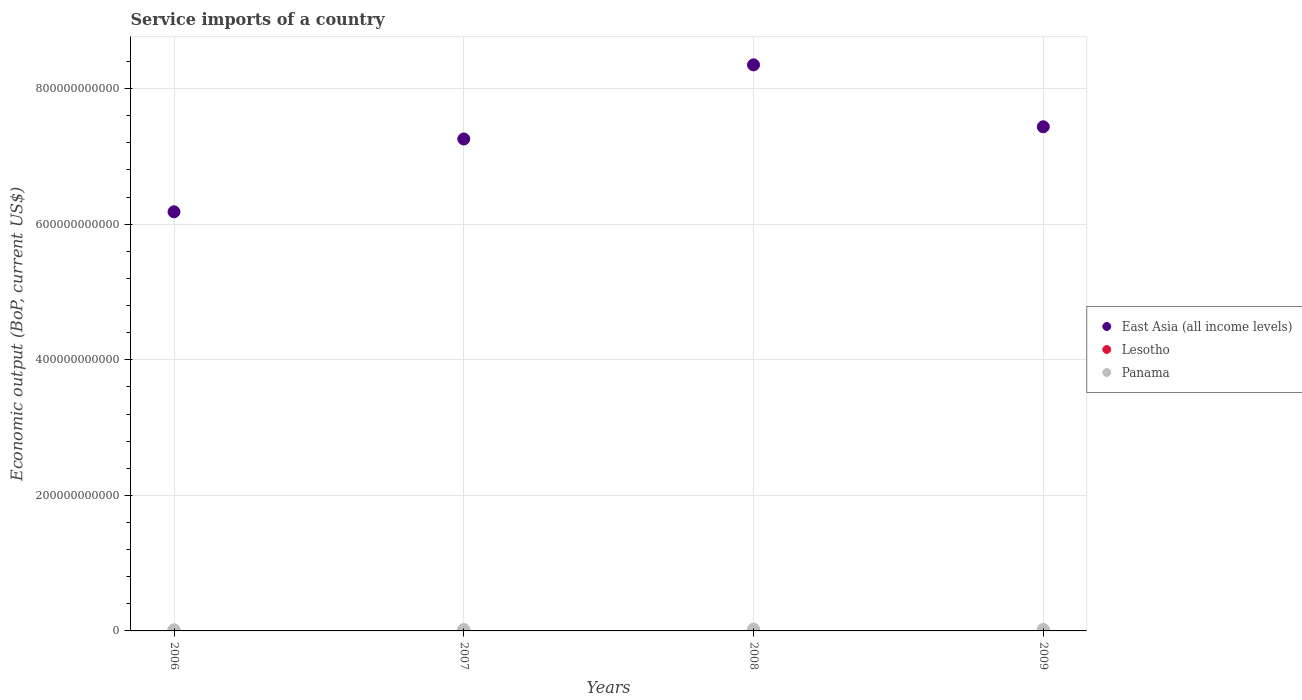Is the number of dotlines equal to the number of legend labels?
Provide a succinct answer. Yes. What is the service imports in Panama in 2006?
Your answer should be compact. 1.70e+09. Across all years, what is the maximum service imports in East Asia (all income levels)?
Offer a terse response. 8.35e+11. Across all years, what is the minimum service imports in Lesotho?
Offer a terse response. 3.76e+08. In which year was the service imports in Lesotho minimum?
Make the answer very short. 2007. What is the total service imports in East Asia (all income levels) in the graph?
Provide a short and direct response. 2.92e+12. What is the difference between the service imports in Panama in 2008 and that in 2009?
Your answer should be compact. 4.44e+08. What is the difference between the service imports in Lesotho in 2006 and the service imports in East Asia (all income levels) in 2009?
Provide a succinct answer. -7.43e+11. What is the average service imports in Lesotho per year?
Provide a short and direct response. 3.97e+08. In the year 2009, what is the difference between the service imports in East Asia (all income levels) and service imports in Panama?
Offer a very short reply. 7.42e+11. In how many years, is the service imports in East Asia (all income levels) greater than 800000000000 US$?
Provide a short and direct response. 1. What is the ratio of the service imports in Panama in 2007 to that in 2008?
Keep it short and to the point. 0.79. What is the difference between the highest and the second highest service imports in Lesotho?
Provide a short and direct response. 2.65e+07. What is the difference between the highest and the lowest service imports in Panama?
Give a very brief answer. 9.38e+08. In how many years, is the service imports in Panama greater than the average service imports in Panama taken over all years?
Offer a terse response. 2. Does the service imports in East Asia (all income levels) monotonically increase over the years?
Ensure brevity in your answer.  No. Is the service imports in Lesotho strictly less than the service imports in East Asia (all income levels) over the years?
Your response must be concise. Yes. How many years are there in the graph?
Offer a very short reply. 4. What is the difference between two consecutive major ticks on the Y-axis?
Your answer should be very brief. 2.00e+11. Where does the legend appear in the graph?
Your response must be concise. Center right. How many legend labels are there?
Make the answer very short. 3. How are the legend labels stacked?
Provide a short and direct response. Vertical. What is the title of the graph?
Offer a terse response. Service imports of a country. Does "Uzbekistan" appear as one of the legend labels in the graph?
Your answer should be compact. No. What is the label or title of the X-axis?
Make the answer very short. Years. What is the label or title of the Y-axis?
Your response must be concise. Economic output (BoP, current US$). What is the Economic output (BoP, current US$) in East Asia (all income levels) in 2006?
Provide a succinct answer. 6.18e+11. What is the Economic output (BoP, current US$) in Lesotho in 2006?
Keep it short and to the point. 3.78e+08. What is the Economic output (BoP, current US$) of Panama in 2006?
Offer a very short reply. 1.70e+09. What is the Economic output (BoP, current US$) of East Asia (all income levels) in 2007?
Provide a short and direct response. 7.26e+11. What is the Economic output (BoP, current US$) in Lesotho in 2007?
Make the answer very short. 3.76e+08. What is the Economic output (BoP, current US$) in Panama in 2007?
Offer a terse response. 2.09e+09. What is the Economic output (BoP, current US$) of East Asia (all income levels) in 2008?
Keep it short and to the point. 8.35e+11. What is the Economic output (BoP, current US$) of Lesotho in 2008?
Ensure brevity in your answer.  4.04e+08. What is the Economic output (BoP, current US$) in Panama in 2008?
Provide a short and direct response. 2.63e+09. What is the Economic output (BoP, current US$) in East Asia (all income levels) in 2009?
Give a very brief answer. 7.44e+11. What is the Economic output (BoP, current US$) of Lesotho in 2009?
Provide a short and direct response. 4.30e+08. What is the Economic output (BoP, current US$) in Panama in 2009?
Offer a terse response. 2.19e+09. Across all years, what is the maximum Economic output (BoP, current US$) in East Asia (all income levels)?
Your answer should be very brief. 8.35e+11. Across all years, what is the maximum Economic output (BoP, current US$) of Lesotho?
Ensure brevity in your answer.  4.30e+08. Across all years, what is the maximum Economic output (BoP, current US$) of Panama?
Offer a terse response. 2.63e+09. Across all years, what is the minimum Economic output (BoP, current US$) in East Asia (all income levels)?
Your response must be concise. 6.18e+11. Across all years, what is the minimum Economic output (BoP, current US$) of Lesotho?
Your answer should be compact. 3.76e+08. Across all years, what is the minimum Economic output (BoP, current US$) of Panama?
Offer a very short reply. 1.70e+09. What is the total Economic output (BoP, current US$) in East Asia (all income levels) in the graph?
Your answer should be compact. 2.92e+12. What is the total Economic output (BoP, current US$) in Lesotho in the graph?
Your response must be concise. 1.59e+09. What is the total Economic output (BoP, current US$) in Panama in the graph?
Ensure brevity in your answer.  8.61e+09. What is the difference between the Economic output (BoP, current US$) in East Asia (all income levels) in 2006 and that in 2007?
Offer a very short reply. -1.07e+11. What is the difference between the Economic output (BoP, current US$) of Lesotho in 2006 and that in 2007?
Provide a short and direct response. 2.02e+06. What is the difference between the Economic output (BoP, current US$) in Panama in 2006 and that in 2007?
Provide a short and direct response. -3.97e+08. What is the difference between the Economic output (BoP, current US$) in East Asia (all income levels) in 2006 and that in 2008?
Ensure brevity in your answer.  -2.17e+11. What is the difference between the Economic output (BoP, current US$) in Lesotho in 2006 and that in 2008?
Keep it short and to the point. -2.61e+07. What is the difference between the Economic output (BoP, current US$) of Panama in 2006 and that in 2008?
Your answer should be compact. -9.38e+08. What is the difference between the Economic output (BoP, current US$) of East Asia (all income levels) in 2006 and that in 2009?
Offer a very short reply. -1.25e+11. What is the difference between the Economic output (BoP, current US$) of Lesotho in 2006 and that in 2009?
Make the answer very short. -5.26e+07. What is the difference between the Economic output (BoP, current US$) of Panama in 2006 and that in 2009?
Ensure brevity in your answer.  -4.95e+08. What is the difference between the Economic output (BoP, current US$) in East Asia (all income levels) in 2007 and that in 2008?
Keep it short and to the point. -1.09e+11. What is the difference between the Economic output (BoP, current US$) of Lesotho in 2007 and that in 2008?
Your answer should be compact. -2.82e+07. What is the difference between the Economic output (BoP, current US$) in Panama in 2007 and that in 2008?
Your answer should be compact. -5.41e+08. What is the difference between the Economic output (BoP, current US$) of East Asia (all income levels) in 2007 and that in 2009?
Keep it short and to the point. -1.80e+1. What is the difference between the Economic output (BoP, current US$) of Lesotho in 2007 and that in 2009?
Offer a very short reply. -5.46e+07. What is the difference between the Economic output (BoP, current US$) of Panama in 2007 and that in 2009?
Provide a succinct answer. -9.79e+07. What is the difference between the Economic output (BoP, current US$) in East Asia (all income levels) in 2008 and that in 2009?
Provide a short and direct response. 9.13e+1. What is the difference between the Economic output (BoP, current US$) in Lesotho in 2008 and that in 2009?
Ensure brevity in your answer.  -2.65e+07. What is the difference between the Economic output (BoP, current US$) of Panama in 2008 and that in 2009?
Give a very brief answer. 4.44e+08. What is the difference between the Economic output (BoP, current US$) of East Asia (all income levels) in 2006 and the Economic output (BoP, current US$) of Lesotho in 2007?
Offer a very short reply. 6.18e+11. What is the difference between the Economic output (BoP, current US$) of East Asia (all income levels) in 2006 and the Economic output (BoP, current US$) of Panama in 2007?
Keep it short and to the point. 6.16e+11. What is the difference between the Economic output (BoP, current US$) in Lesotho in 2006 and the Economic output (BoP, current US$) in Panama in 2007?
Provide a short and direct response. -1.72e+09. What is the difference between the Economic output (BoP, current US$) of East Asia (all income levels) in 2006 and the Economic output (BoP, current US$) of Lesotho in 2008?
Your answer should be very brief. 6.18e+11. What is the difference between the Economic output (BoP, current US$) of East Asia (all income levels) in 2006 and the Economic output (BoP, current US$) of Panama in 2008?
Make the answer very short. 6.16e+11. What is the difference between the Economic output (BoP, current US$) in Lesotho in 2006 and the Economic output (BoP, current US$) in Panama in 2008?
Provide a short and direct response. -2.26e+09. What is the difference between the Economic output (BoP, current US$) in East Asia (all income levels) in 2006 and the Economic output (BoP, current US$) in Lesotho in 2009?
Keep it short and to the point. 6.18e+11. What is the difference between the Economic output (BoP, current US$) of East Asia (all income levels) in 2006 and the Economic output (BoP, current US$) of Panama in 2009?
Make the answer very short. 6.16e+11. What is the difference between the Economic output (BoP, current US$) of Lesotho in 2006 and the Economic output (BoP, current US$) of Panama in 2009?
Keep it short and to the point. -1.81e+09. What is the difference between the Economic output (BoP, current US$) of East Asia (all income levels) in 2007 and the Economic output (BoP, current US$) of Lesotho in 2008?
Make the answer very short. 7.25e+11. What is the difference between the Economic output (BoP, current US$) of East Asia (all income levels) in 2007 and the Economic output (BoP, current US$) of Panama in 2008?
Your answer should be very brief. 7.23e+11. What is the difference between the Economic output (BoP, current US$) in Lesotho in 2007 and the Economic output (BoP, current US$) in Panama in 2008?
Provide a short and direct response. -2.26e+09. What is the difference between the Economic output (BoP, current US$) of East Asia (all income levels) in 2007 and the Economic output (BoP, current US$) of Lesotho in 2009?
Keep it short and to the point. 7.25e+11. What is the difference between the Economic output (BoP, current US$) of East Asia (all income levels) in 2007 and the Economic output (BoP, current US$) of Panama in 2009?
Give a very brief answer. 7.24e+11. What is the difference between the Economic output (BoP, current US$) of Lesotho in 2007 and the Economic output (BoP, current US$) of Panama in 2009?
Make the answer very short. -1.82e+09. What is the difference between the Economic output (BoP, current US$) in East Asia (all income levels) in 2008 and the Economic output (BoP, current US$) in Lesotho in 2009?
Your response must be concise. 8.35e+11. What is the difference between the Economic output (BoP, current US$) in East Asia (all income levels) in 2008 and the Economic output (BoP, current US$) in Panama in 2009?
Provide a succinct answer. 8.33e+11. What is the difference between the Economic output (BoP, current US$) of Lesotho in 2008 and the Economic output (BoP, current US$) of Panama in 2009?
Offer a very short reply. -1.79e+09. What is the average Economic output (BoP, current US$) of East Asia (all income levels) per year?
Ensure brevity in your answer.  7.31e+11. What is the average Economic output (BoP, current US$) in Lesotho per year?
Ensure brevity in your answer.  3.97e+08. What is the average Economic output (BoP, current US$) of Panama per year?
Provide a short and direct response. 2.15e+09. In the year 2006, what is the difference between the Economic output (BoP, current US$) in East Asia (all income levels) and Economic output (BoP, current US$) in Lesotho?
Your answer should be compact. 6.18e+11. In the year 2006, what is the difference between the Economic output (BoP, current US$) in East Asia (all income levels) and Economic output (BoP, current US$) in Panama?
Your answer should be very brief. 6.17e+11. In the year 2006, what is the difference between the Economic output (BoP, current US$) of Lesotho and Economic output (BoP, current US$) of Panama?
Provide a short and direct response. -1.32e+09. In the year 2007, what is the difference between the Economic output (BoP, current US$) of East Asia (all income levels) and Economic output (BoP, current US$) of Lesotho?
Provide a succinct answer. 7.25e+11. In the year 2007, what is the difference between the Economic output (BoP, current US$) of East Asia (all income levels) and Economic output (BoP, current US$) of Panama?
Provide a short and direct response. 7.24e+11. In the year 2007, what is the difference between the Economic output (BoP, current US$) of Lesotho and Economic output (BoP, current US$) of Panama?
Your answer should be compact. -1.72e+09. In the year 2008, what is the difference between the Economic output (BoP, current US$) of East Asia (all income levels) and Economic output (BoP, current US$) of Lesotho?
Make the answer very short. 8.35e+11. In the year 2008, what is the difference between the Economic output (BoP, current US$) of East Asia (all income levels) and Economic output (BoP, current US$) of Panama?
Your answer should be compact. 8.32e+11. In the year 2008, what is the difference between the Economic output (BoP, current US$) in Lesotho and Economic output (BoP, current US$) in Panama?
Provide a short and direct response. -2.23e+09. In the year 2009, what is the difference between the Economic output (BoP, current US$) in East Asia (all income levels) and Economic output (BoP, current US$) in Lesotho?
Offer a very short reply. 7.43e+11. In the year 2009, what is the difference between the Economic output (BoP, current US$) in East Asia (all income levels) and Economic output (BoP, current US$) in Panama?
Keep it short and to the point. 7.42e+11. In the year 2009, what is the difference between the Economic output (BoP, current US$) in Lesotho and Economic output (BoP, current US$) in Panama?
Make the answer very short. -1.76e+09. What is the ratio of the Economic output (BoP, current US$) of East Asia (all income levels) in 2006 to that in 2007?
Provide a succinct answer. 0.85. What is the ratio of the Economic output (BoP, current US$) of Lesotho in 2006 to that in 2007?
Your answer should be very brief. 1.01. What is the ratio of the Economic output (BoP, current US$) of Panama in 2006 to that in 2007?
Your answer should be compact. 0.81. What is the ratio of the Economic output (BoP, current US$) of East Asia (all income levels) in 2006 to that in 2008?
Your answer should be compact. 0.74. What is the ratio of the Economic output (BoP, current US$) in Lesotho in 2006 to that in 2008?
Make the answer very short. 0.94. What is the ratio of the Economic output (BoP, current US$) of Panama in 2006 to that in 2008?
Keep it short and to the point. 0.64. What is the ratio of the Economic output (BoP, current US$) of East Asia (all income levels) in 2006 to that in 2009?
Make the answer very short. 0.83. What is the ratio of the Economic output (BoP, current US$) of Lesotho in 2006 to that in 2009?
Keep it short and to the point. 0.88. What is the ratio of the Economic output (BoP, current US$) in Panama in 2006 to that in 2009?
Provide a short and direct response. 0.77. What is the ratio of the Economic output (BoP, current US$) of East Asia (all income levels) in 2007 to that in 2008?
Provide a short and direct response. 0.87. What is the ratio of the Economic output (BoP, current US$) of Lesotho in 2007 to that in 2008?
Ensure brevity in your answer.  0.93. What is the ratio of the Economic output (BoP, current US$) in Panama in 2007 to that in 2008?
Your response must be concise. 0.79. What is the ratio of the Economic output (BoP, current US$) of East Asia (all income levels) in 2007 to that in 2009?
Provide a succinct answer. 0.98. What is the ratio of the Economic output (BoP, current US$) of Lesotho in 2007 to that in 2009?
Make the answer very short. 0.87. What is the ratio of the Economic output (BoP, current US$) in Panama in 2007 to that in 2009?
Ensure brevity in your answer.  0.96. What is the ratio of the Economic output (BoP, current US$) of East Asia (all income levels) in 2008 to that in 2009?
Provide a succinct answer. 1.12. What is the ratio of the Economic output (BoP, current US$) of Lesotho in 2008 to that in 2009?
Provide a short and direct response. 0.94. What is the ratio of the Economic output (BoP, current US$) in Panama in 2008 to that in 2009?
Ensure brevity in your answer.  1.2. What is the difference between the highest and the second highest Economic output (BoP, current US$) of East Asia (all income levels)?
Your answer should be very brief. 9.13e+1. What is the difference between the highest and the second highest Economic output (BoP, current US$) in Lesotho?
Give a very brief answer. 2.65e+07. What is the difference between the highest and the second highest Economic output (BoP, current US$) in Panama?
Your answer should be very brief. 4.44e+08. What is the difference between the highest and the lowest Economic output (BoP, current US$) of East Asia (all income levels)?
Your answer should be compact. 2.17e+11. What is the difference between the highest and the lowest Economic output (BoP, current US$) in Lesotho?
Offer a terse response. 5.46e+07. What is the difference between the highest and the lowest Economic output (BoP, current US$) in Panama?
Your answer should be compact. 9.38e+08. 